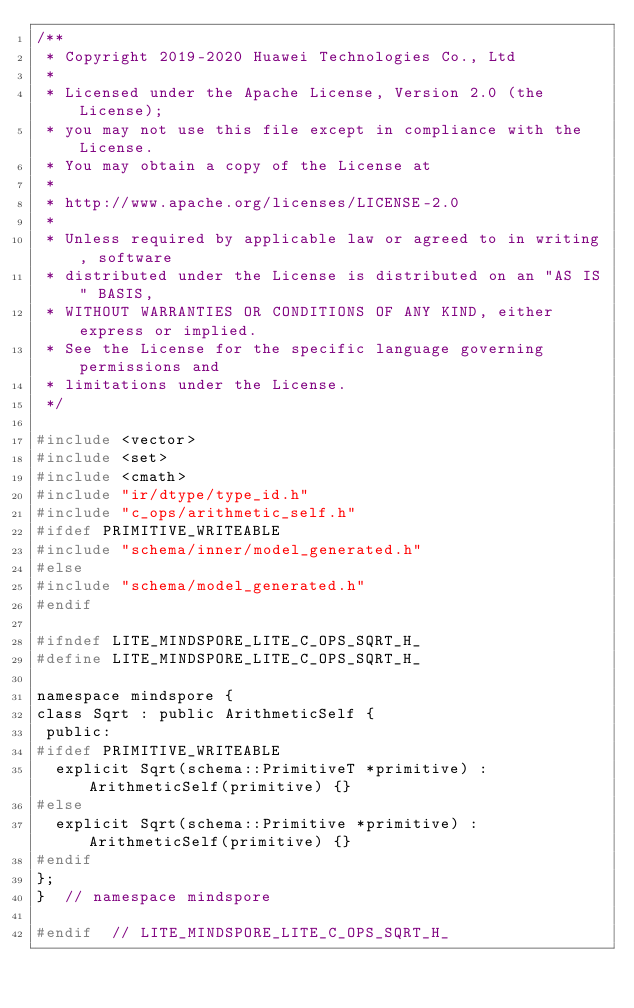<code> <loc_0><loc_0><loc_500><loc_500><_C_>/**
 * Copyright 2019-2020 Huawei Technologies Co., Ltd
 *
 * Licensed under the Apache License, Version 2.0 (the License);
 * you may not use this file except in compliance with the License.
 * You may obtain a copy of the License at
 *
 * http://www.apache.org/licenses/LICENSE-2.0
 *
 * Unless required by applicable law or agreed to in writing, software
 * distributed under the License is distributed on an "AS IS" BASIS,
 * WITHOUT WARRANTIES OR CONDITIONS OF ANY KIND, either express or implied.
 * See the License for the specific language governing permissions and
 * limitations under the License.
 */

#include <vector>
#include <set>
#include <cmath>
#include "ir/dtype/type_id.h"
#include "c_ops/arithmetic_self.h"
#ifdef PRIMITIVE_WRITEABLE
#include "schema/inner/model_generated.h"
#else
#include "schema/model_generated.h"
#endif

#ifndef LITE_MINDSPORE_LITE_C_OPS_SQRT_H_
#define LITE_MINDSPORE_LITE_C_OPS_SQRT_H_

namespace mindspore {
class Sqrt : public ArithmeticSelf {
 public:
#ifdef PRIMITIVE_WRITEABLE
  explicit Sqrt(schema::PrimitiveT *primitive) : ArithmeticSelf(primitive) {}
#else
  explicit Sqrt(schema::Primitive *primitive) : ArithmeticSelf(primitive) {}
#endif
};
}  // namespace mindspore

#endif  // LITE_MINDSPORE_LITE_C_OPS_SQRT_H_
</code> 